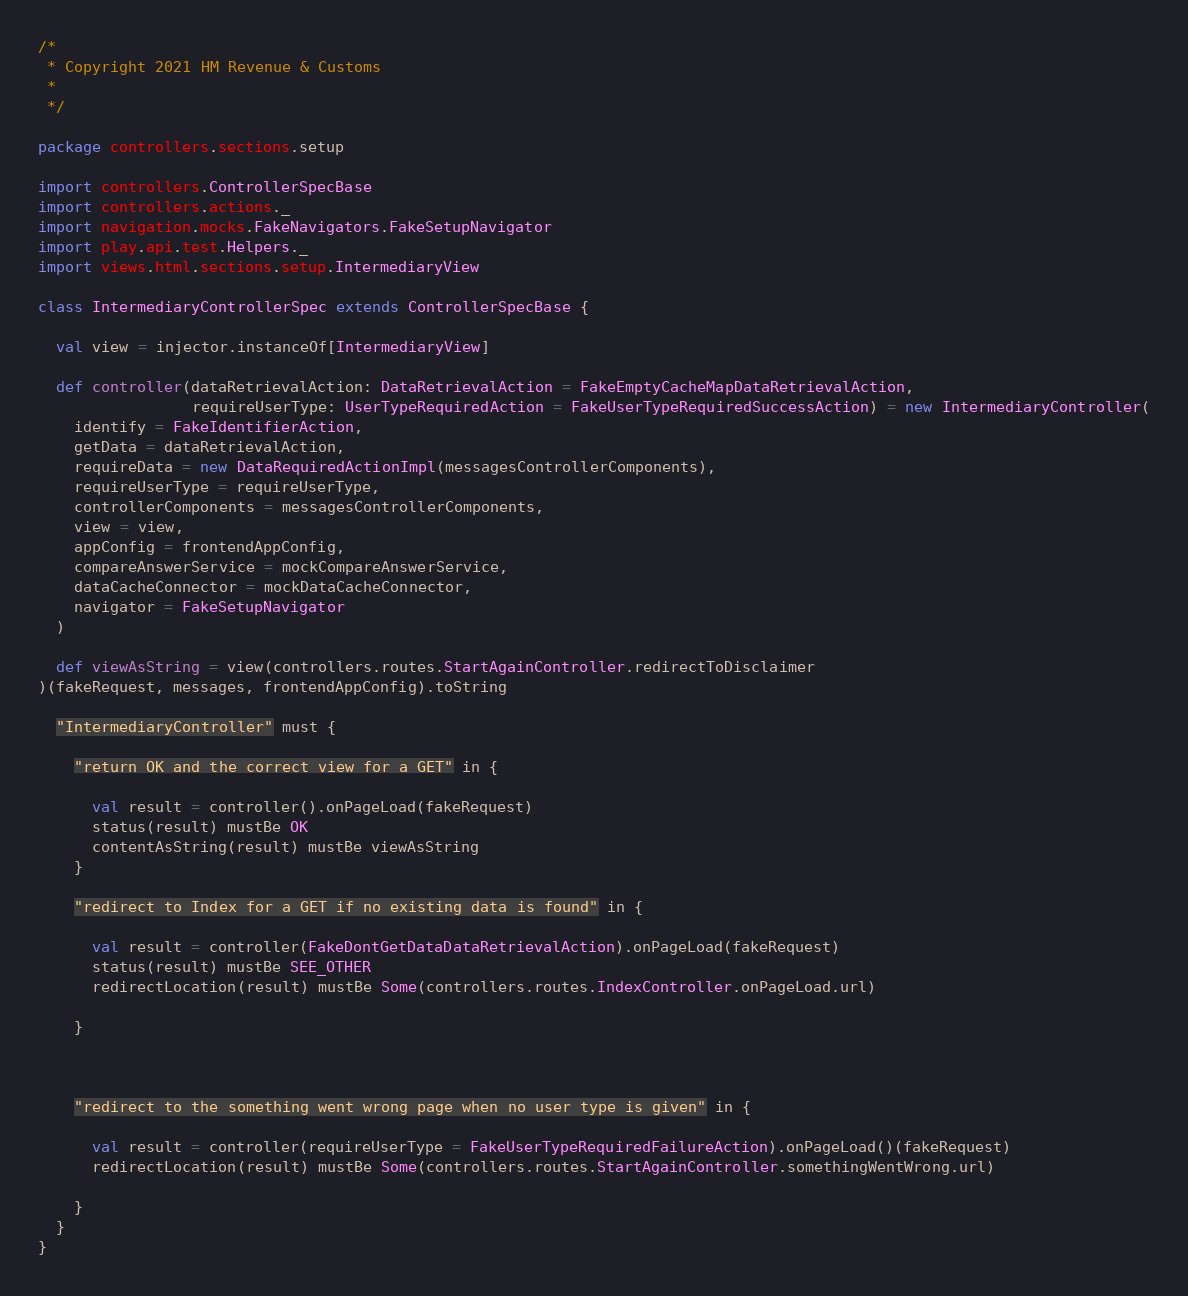Convert code to text. <code><loc_0><loc_0><loc_500><loc_500><_Scala_>/*
 * Copyright 2021 HM Revenue & Customs
 *
 */

package controllers.sections.setup

import controllers.ControllerSpecBase
import controllers.actions._
import navigation.mocks.FakeNavigators.FakeSetupNavigator
import play.api.test.Helpers._
import views.html.sections.setup.IntermediaryView

class IntermediaryControllerSpec extends ControllerSpecBase {

  val view = injector.instanceOf[IntermediaryView]

  def controller(dataRetrievalAction: DataRetrievalAction = FakeEmptyCacheMapDataRetrievalAction,
                 requireUserType: UserTypeRequiredAction = FakeUserTypeRequiredSuccessAction) = new IntermediaryController(
    identify = FakeIdentifierAction,
    getData = dataRetrievalAction,
    requireData = new DataRequiredActionImpl(messagesControllerComponents),
    requireUserType = requireUserType,
    controllerComponents = messagesControllerComponents,
    view = view,
    appConfig = frontendAppConfig,
    compareAnswerService = mockCompareAnswerService,
    dataCacheConnector = mockDataCacheConnector,
    navigator = FakeSetupNavigator
  )

  def viewAsString = view(controllers.routes.StartAgainController.redirectToDisclaimer
)(fakeRequest, messages, frontendAppConfig).toString

  "IntermediaryController" must {

    "return OK and the correct view for a GET" in {

      val result = controller().onPageLoad(fakeRequest)
      status(result) mustBe OK
      contentAsString(result) mustBe viewAsString
    }

    "redirect to Index for a GET if no existing data is found" in {

      val result = controller(FakeDontGetDataDataRetrievalAction).onPageLoad(fakeRequest)
      status(result) mustBe SEE_OTHER
      redirectLocation(result) mustBe Some(controllers.routes.IndexController.onPageLoad.url)

    }



    "redirect to the something went wrong page when no user type is given" in {

      val result = controller(requireUserType = FakeUserTypeRequiredFailureAction).onPageLoad()(fakeRequest)
      redirectLocation(result) mustBe Some(controllers.routes.StartAgainController.somethingWentWrong.url)

    }
  }
}




</code> 